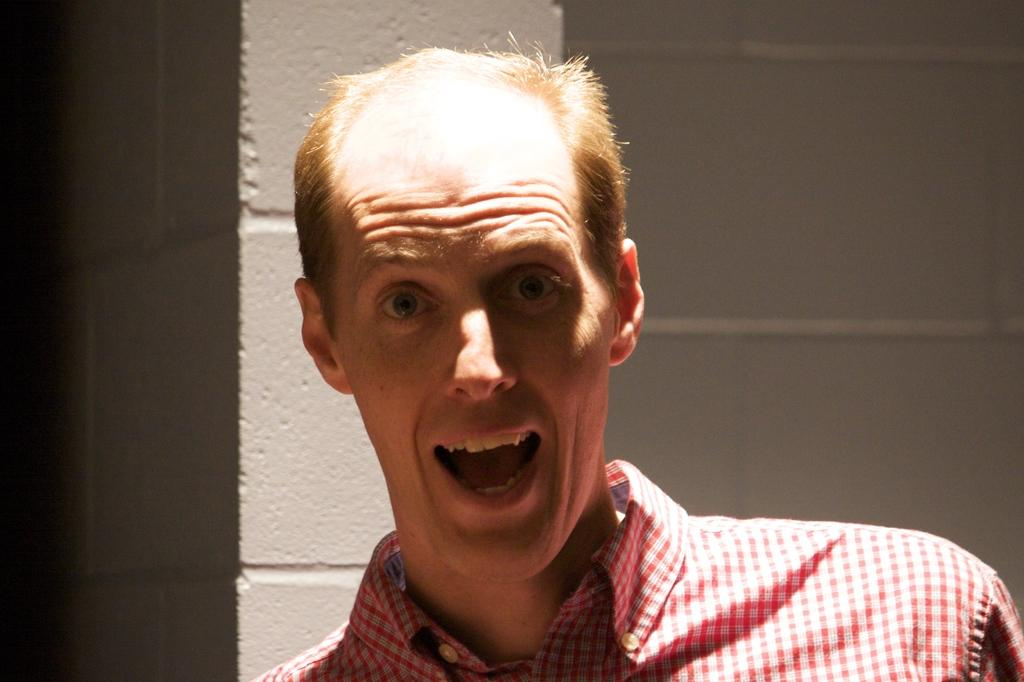What is the main subject of the image? There is a person in the center of the image. What can be seen in the background of the image? There is a wall in the background of the image. What type of acoustics can be heard in the image? There is no information about sound or acoustics in the image, so it cannot be determined from the image. 